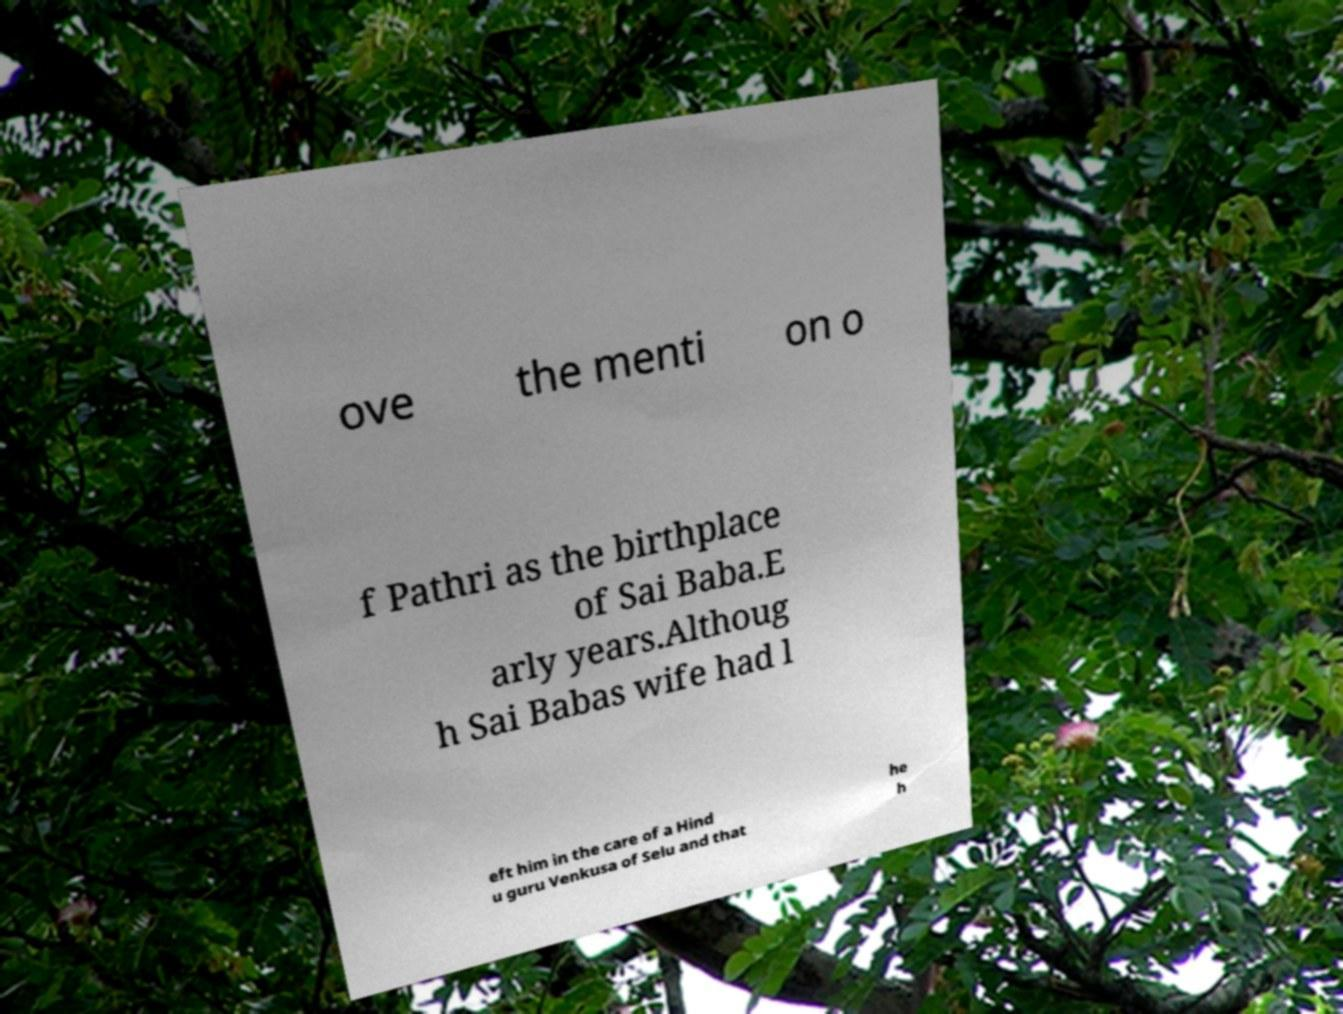There's text embedded in this image that I need extracted. Can you transcribe it verbatim? ove the menti on o f Pathri as the birthplace of Sai Baba.E arly years.Althoug h Sai Babas wife had l eft him in the care of a Hind u guru Venkusa of Selu and that he h 